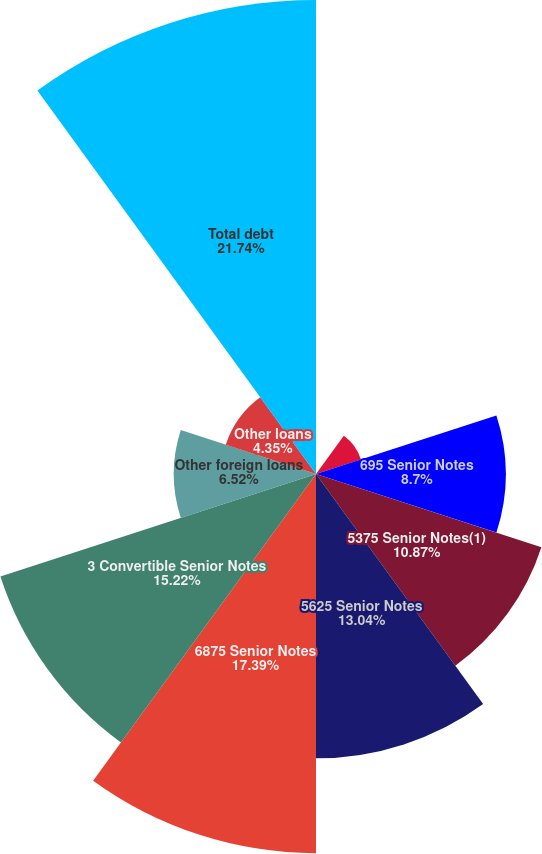Convert chart to OTSL. <chart><loc_0><loc_0><loc_500><loc_500><pie_chart><fcel>Foreign currency forward<fcel>Interest rate swaps<fcel>695 Senior Notes<fcel>5375 Senior Notes(1)<fcel>5625 Senior Notes<fcel>6875 Senior Notes<fcel>3 Convertible Senior Notes<fcel>Other foreign loans<fcel>Other loans<fcel>Total debt<nl><fcel>0.0%<fcel>2.17%<fcel>8.7%<fcel>10.87%<fcel>13.04%<fcel>17.39%<fcel>15.22%<fcel>6.52%<fcel>4.35%<fcel>21.74%<nl></chart> 